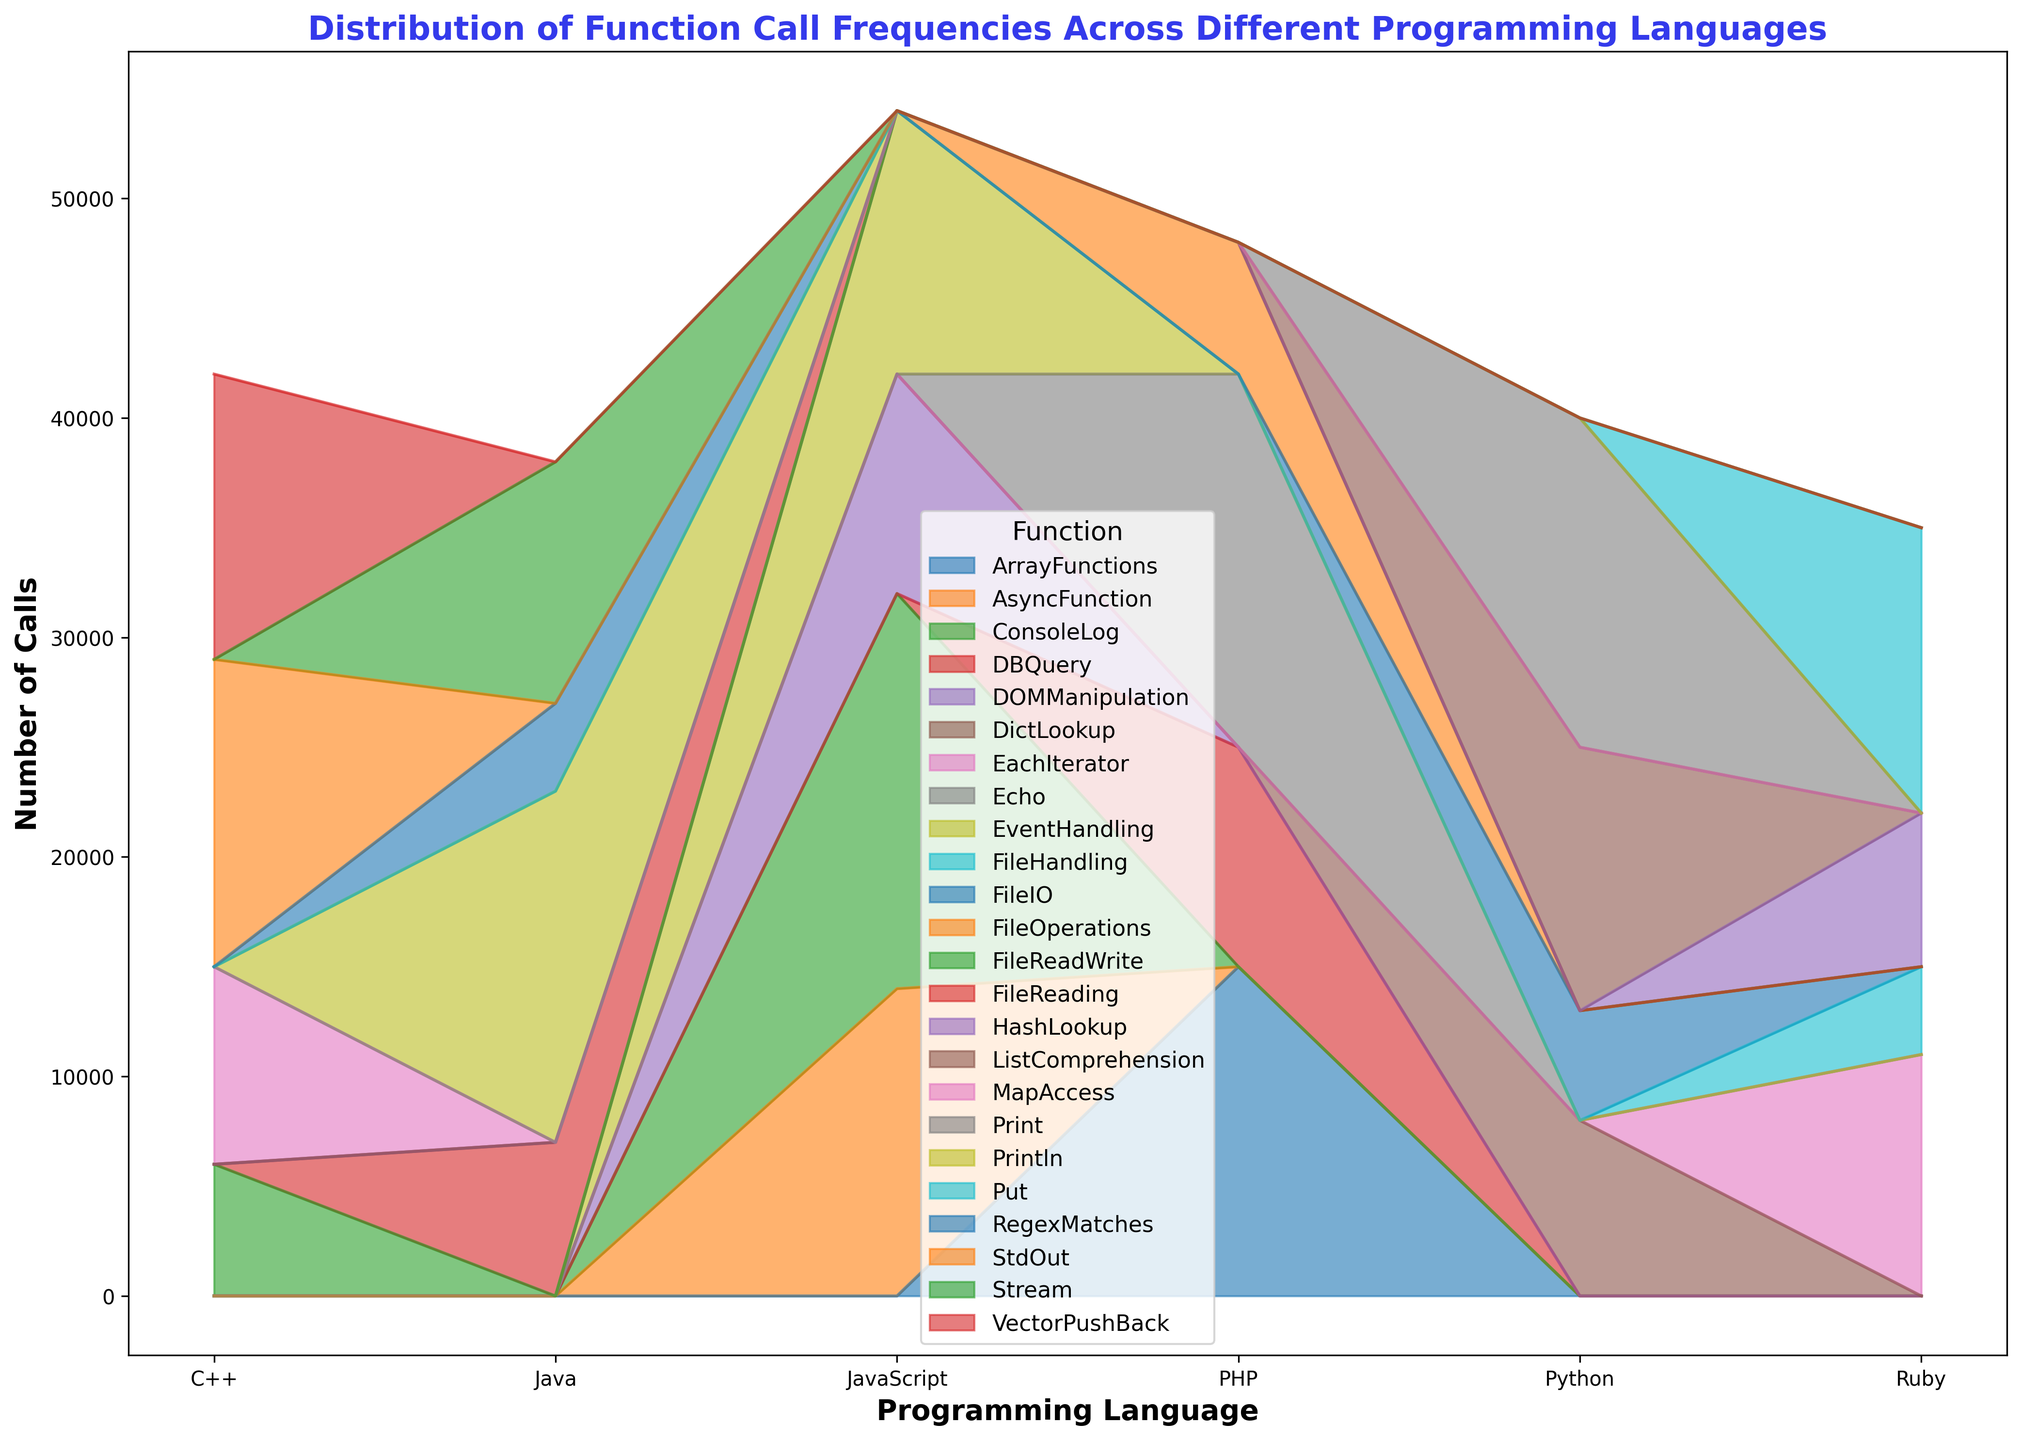Which programming language has the highest number of function calls overall? By observing the area chart, we can see which programming language has the largest cumulative area under its functions. The one with the largest area represents the language with the highest number of function calls.
Answer: JavaScript Which function in Python has the highest number of calls? In the area chart, look at the segment corresponding to Python and identify the function with the largest height. This function has the highest number of calls in Python.
Answer: Print Which functions have more calls in JavaScript compared to Python? Compare the heights of the corresponding function segments between JavaScript and Python. Identify which ones are taller in JavaScript.
Answer: ConsoleLog, AsyncFunction, EventHandling How does the number of calls for ‘FileIO’ in Python compare to 'FileHandling' in Ruby? By examining the height of the segments for 'FileIO' in the Python section and 'FileHandling' in the Ruby section, we can determine which one is taller and therefore has more calls.
Answer: FileIO in Python is higher Which language has fewer calls for 'FileReadWrite/Operations', C++ or PHP? Compare the heights of the segments for 'FileReadWrite' in C++ and 'FileOperations' in PHP. The shorter segment represents the language with fewer calls for that function.
Answer: C++ What is the difference in call volume between 'Println' in Java and 'Put' in Ruby? Identify the heights corresponding to 'Println' in Java and 'Put' in Ruby, then subtract the smaller height from the larger height to find the difference.
Answer: 3000 calls Which function in PHP is called the least frequently? Look at the segments within the PHP section and identify the smallest one to determine the least frequently called function.
Answer: FileOperations What is the total number of calls for 'FileIO', 'FileReading', and 'FileReadWrite' functions across all languages? Sum the heights of the segments corresponding to 'FileIO' in Python, 'FileReading' in Java, and 'FileReadWrite' in C++.
Answer: 18000 calls In which language is the 'DBQuery' function most frequently called? Find the 'DBQuery' function segment and see which language's section has it.
Answer: PHP Which language has the more balanced distribution of function calls, based on the visual appearance? Determine this by observing which language's area segments are most evenly distributed in height, showing a more balanced call frequency across functions.
Answer: Ruby 